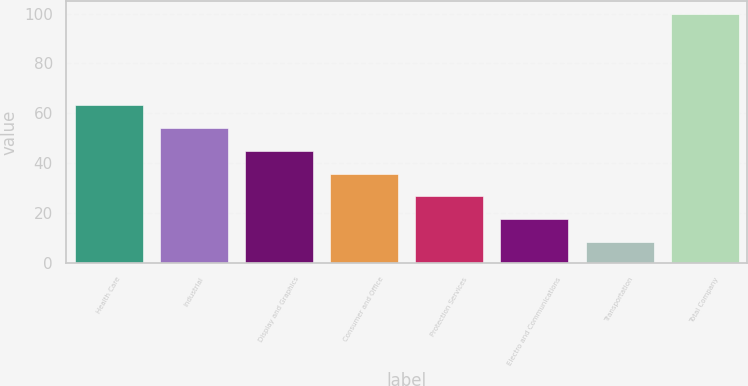Convert chart to OTSL. <chart><loc_0><loc_0><loc_500><loc_500><bar_chart><fcel>Health Care<fcel>Industrial<fcel>Display and Graphics<fcel>Consumer and Office<fcel>Protection Services<fcel>Electro and Communications<fcel>Transportation<fcel>Total Company<nl><fcel>63.36<fcel>54.2<fcel>45.04<fcel>35.88<fcel>26.72<fcel>17.56<fcel>8.4<fcel>100<nl></chart> 